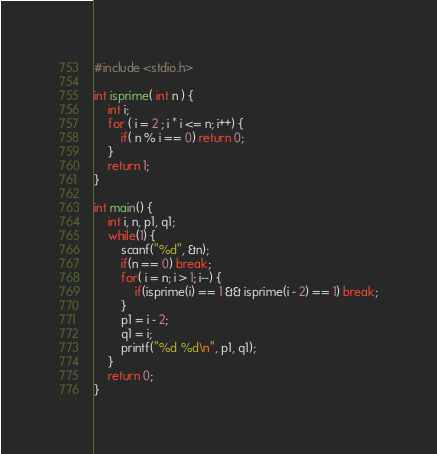<code> <loc_0><loc_0><loc_500><loc_500><_C_>#include <stdio.h>

int isprime( int n ) {
	int i;
	for ( i = 2 ; i * i <= n; i++) {
		if( n % i == 0) return 0;
	}
	return 1;
}

int main() {
	int i, n, p1, q1;
	while(1) {
		scanf("%d", &n);
		if(n == 0) break;
		for( i = n; i > 1; i--) {
			if(isprime(i) == 1 && isprime(i - 2) == 1) break;
		}
		p1 = i - 2;
		q1 = i;
		printf("%d %d\n", p1, q1);
	}
	return 0;
}</code> 